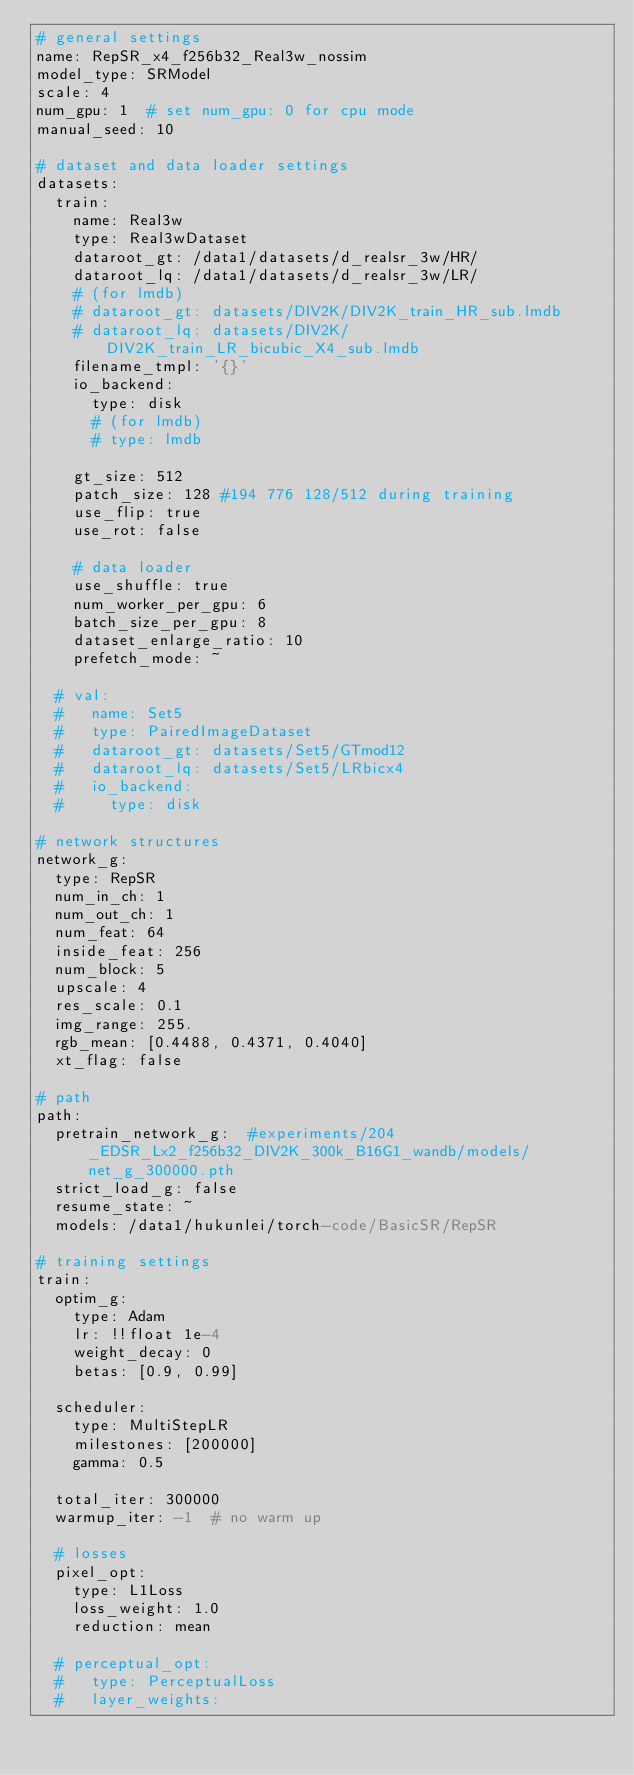Convert code to text. <code><loc_0><loc_0><loc_500><loc_500><_YAML_># general settings
name: RepSR_x4_f256b32_Real3w_nossim
model_type: SRModel
scale: 4
num_gpu: 1  # set num_gpu: 0 for cpu mode
manual_seed: 10

# dataset and data loader settings
datasets:
  train:
    name: Real3w
    type: Real3wDataset
    dataroot_gt: /data1/datasets/d_realsr_3w/HR/
    dataroot_lq: /data1/datasets/d_realsr_3w/LR/
    # (for lmdb)
    # dataroot_gt: datasets/DIV2K/DIV2K_train_HR_sub.lmdb
    # dataroot_lq: datasets/DIV2K/DIV2K_train_LR_bicubic_X4_sub.lmdb
    filename_tmpl: '{}'
    io_backend:
      type: disk
      # (for lmdb)
      # type: lmdb

    gt_size: 512  
    patch_size: 128 #194 776 128/512 during training
    use_flip: true
    use_rot: false

    # data loader
    use_shuffle: true
    num_worker_per_gpu: 6
    batch_size_per_gpu: 8
    dataset_enlarge_ratio: 10
    prefetch_mode: ~

  # val:
  #   name: Set5
  #   type: PairedImageDataset
  #   dataroot_gt: datasets/Set5/GTmod12
  #   dataroot_lq: datasets/Set5/LRbicx4
  #   io_backend:
  #     type: disk

# network structures
network_g:
  type: RepSR
  num_in_ch: 1
  num_out_ch: 1
  num_feat: 64
  inside_feat: 256
  num_block: 5
  upscale: 4
  res_scale: 0.1
  img_range: 255.
  rgb_mean: [0.4488, 0.4371, 0.4040]
  xt_flag: false

# path
path:
  pretrain_network_g:  #experiments/204_EDSR_Lx2_f256b32_DIV2K_300k_B16G1_wandb/models/net_g_300000.pth
  strict_load_g: false
  resume_state: ~
  models: /data1/hukunlei/torch-code/BasicSR/RepSR

# training settings
train:
  optim_g:
    type: Adam
    lr: !!float 1e-4
    weight_decay: 0
    betas: [0.9, 0.99]

  scheduler:
    type: MultiStepLR
    milestones: [200000]
    gamma: 0.5

  total_iter: 300000
  warmup_iter: -1  # no warm up

  # losses
  pixel_opt:
    type: L1Loss
    loss_weight: 1.0
    reduction: mean
  
  # perceptual_opt:
  #   type: PerceptualLoss
  #   layer_weights:</code> 